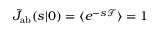<formula> <loc_0><loc_0><loc_500><loc_500>\tilde { J } _ { a b } ( s | \ r _ { 0 } ) = \langle e ^ { - s \mathcal { T } } \rangle = 1</formula> 